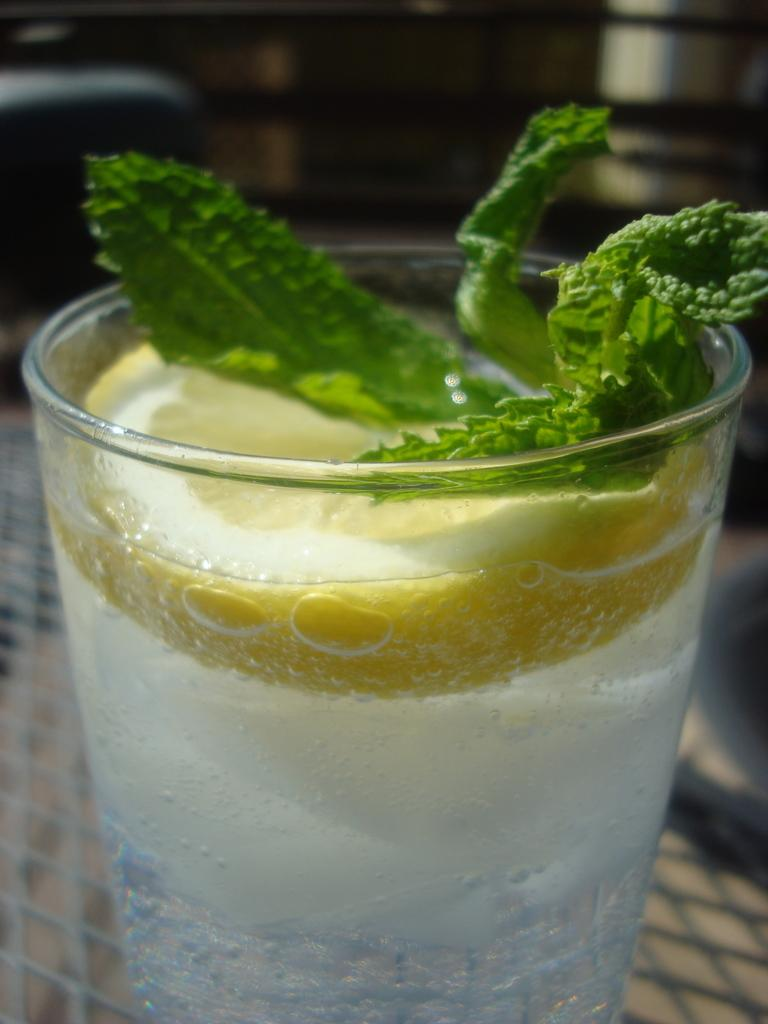What is the main feature of the image? The main feature of the image is grass with liquid and a lemon slice. What else can be seen in the grass? There are leaves in the grass. Where is the grass located? The grass is on a platform. What is visible in the background of the image? The background of the image contains some objects. How would you describe the clarity of the image? The image is not clear. What is the size of the gate in the image? There is no gate present in the image. How does the grass help with learning in the image? The image does not depict any learning activities, and the grass is not associated with learning. 